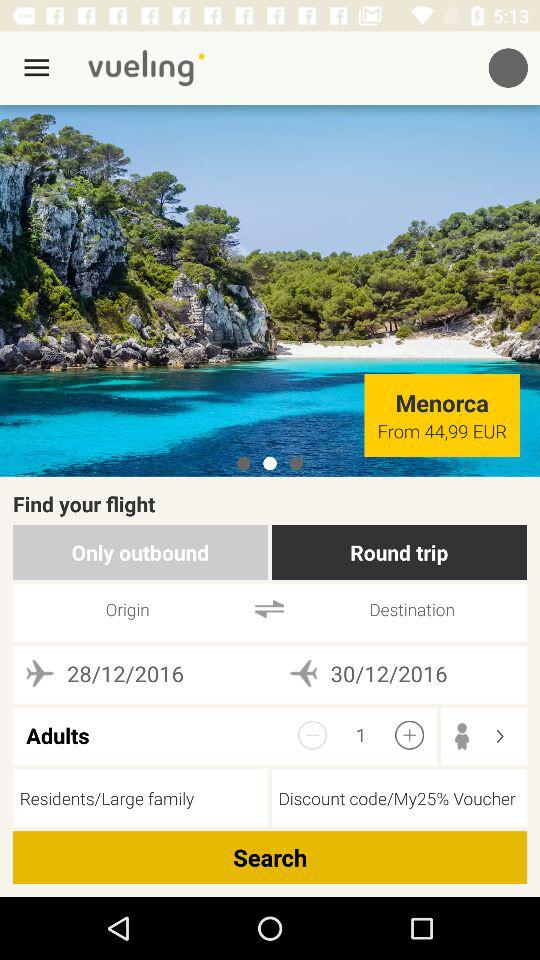What is the origin date? The origin date is 28/12/2016. 